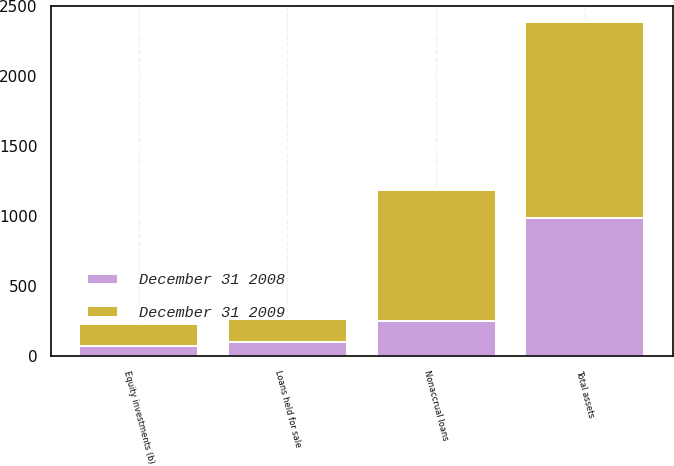Convert chart. <chart><loc_0><loc_0><loc_500><loc_500><stacked_bar_chart><ecel><fcel>Nonaccrual loans<fcel>Loans held for sale<fcel>Equity investments (b)<fcel>Total assets<nl><fcel>December 31 2009<fcel>939<fcel>168<fcel>154<fcel>1400<nl><fcel>December 31 2008<fcel>250<fcel>101<fcel>75<fcel>986<nl></chart> 